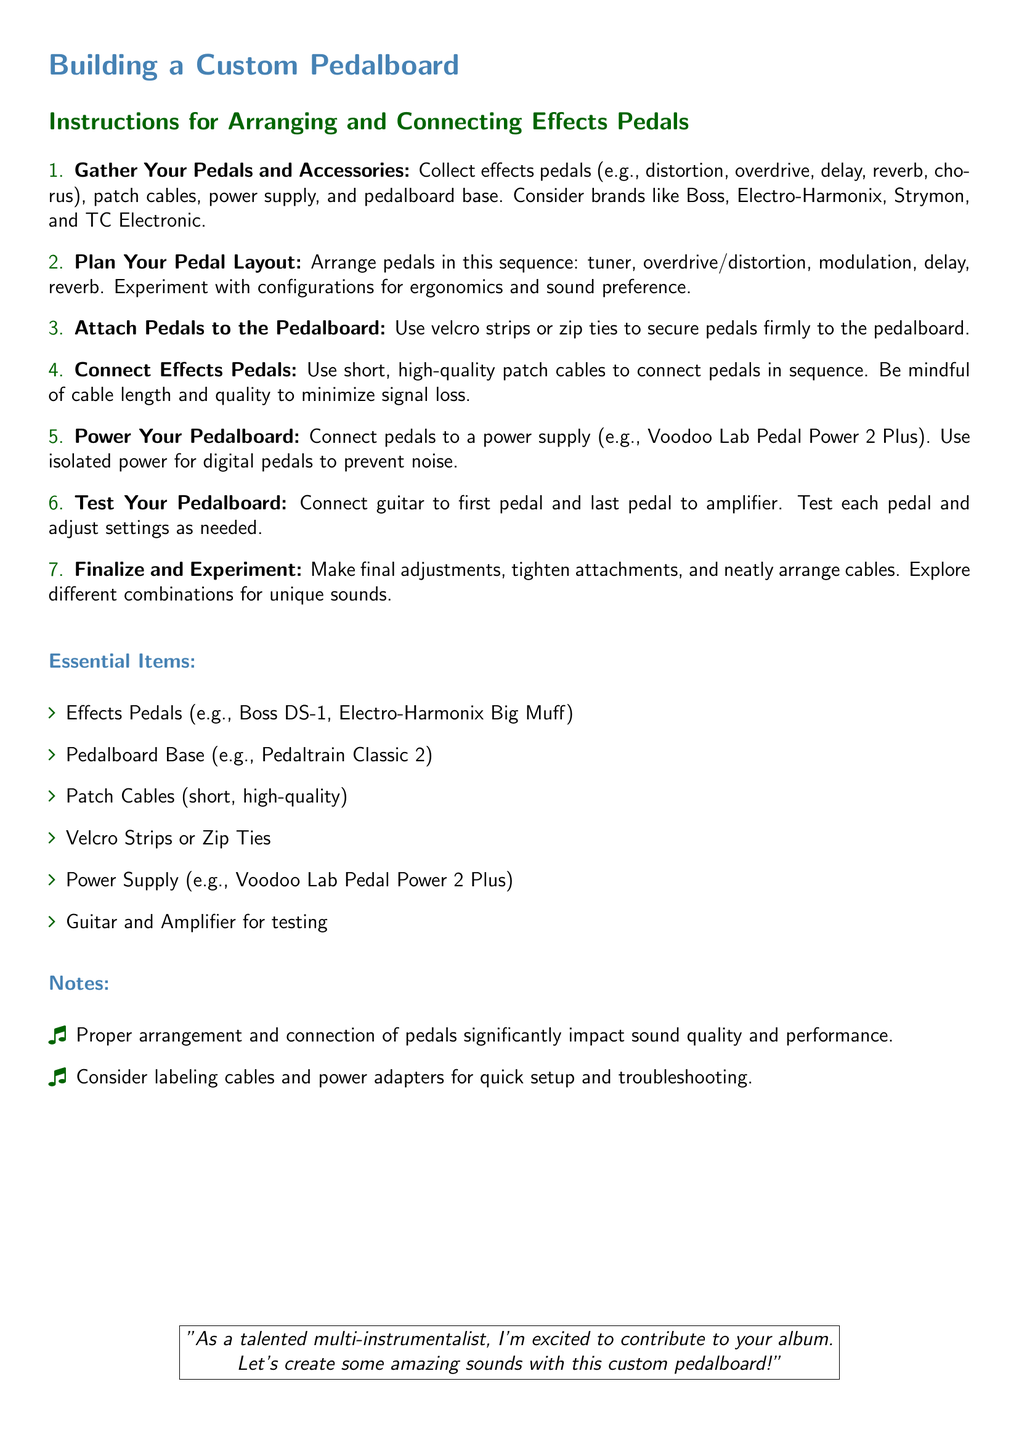What is the first step in building a custom pedalboard? The first step is to gather effects pedals and accessories.
Answer: Gather Your Pedals and Accessories What type of cables should be used to connect the pedals? The document specifies to use short, high-quality patch cables for connections.
Answer: Short, high-quality patch cables Which brand is mentioned for the power supply? The document mentions Voodoo Lab as the brand for the power supply.
Answer: Voodoo Lab What is the recommended order for arranging pedals? The recommended order is tuner, overdrive/distortion, modulation, delay, reverb.
Answer: Tuner, overdrive/distortion, modulation, delay, reverb What should be done after testing the pedalboard? After testing, it suggests to make final adjustments and explore different combinations.
Answer: Make final adjustments and explore combinations How should pedals be secured to the pedalboard? The document advises using velcro strips or zip ties for securing pedals.
Answer: Velcro strips or zip ties What is an essential item listed for testing the pedalboard? The document lists a guitar and amplifier as essential items for testing.
Answer: Guitar and amplifier What impact does proper arrangement have according to the notes? Proper arrangement significantly impacts sound quality and performance.
Answer: Sound quality and performance What should be considered for quick setup and troubleshooting? The document suggests labeling cables and power adapters.
Answer: Labeling cables and power adapters 